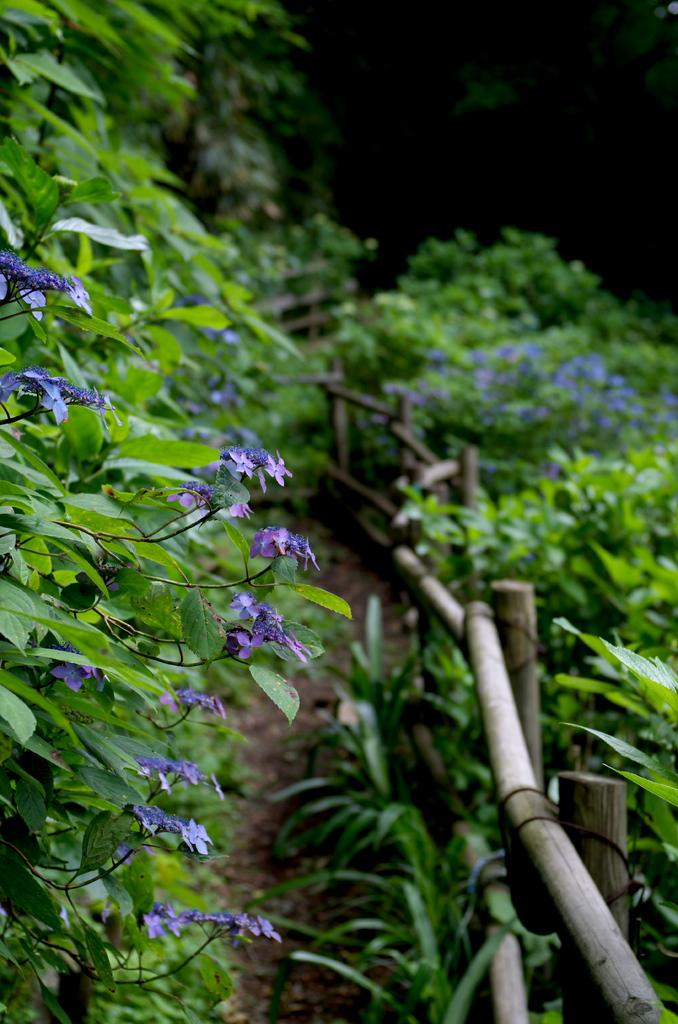What type of plants can be seen in the image? There are plants with flowers in the image. What material is the fencing made of in the image? The fencing in the image is made of wood. Can you describe the background of the image? The background of the image is blurred. How many planes can be seen flying over the plants in the image? There are no planes visible in the image; it only features plants with flowers and a wooden fencing. 